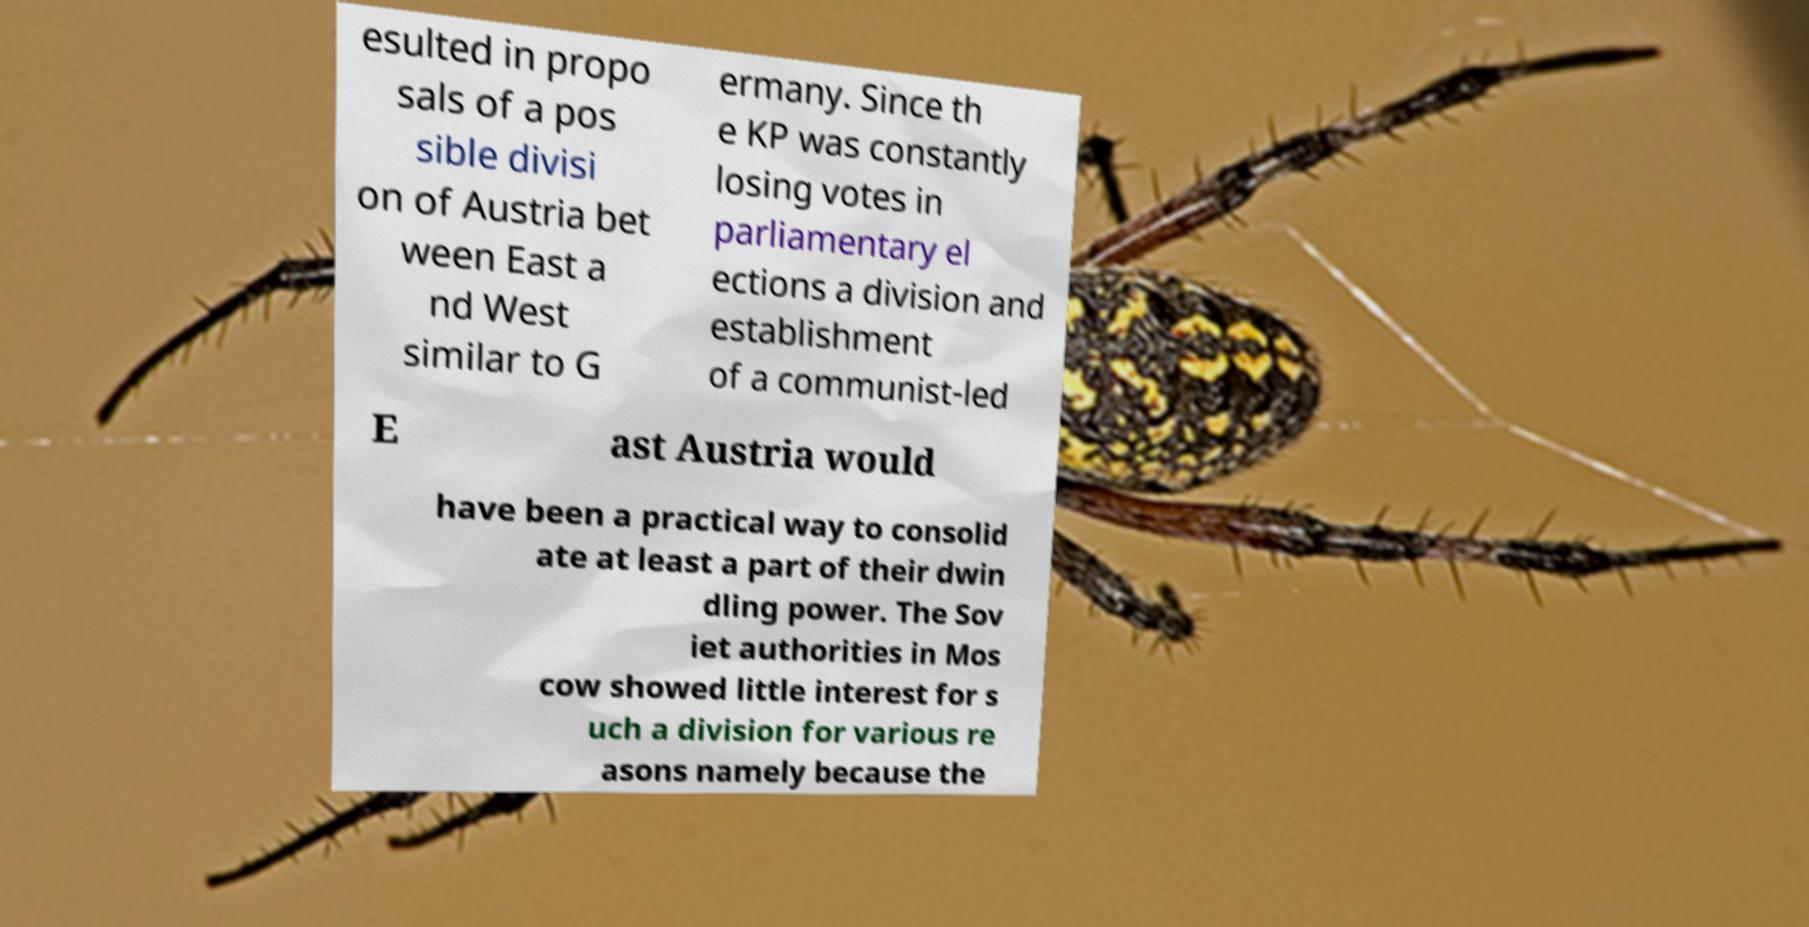Could you assist in decoding the text presented in this image and type it out clearly? esulted in propo sals of a pos sible divisi on of Austria bet ween East a nd West similar to G ermany. Since th e KP was constantly losing votes in parliamentary el ections a division and establishment of a communist-led E ast Austria would have been a practical way to consolid ate at least a part of their dwin dling power. The Sov iet authorities in Mos cow showed little interest for s uch a division for various re asons namely because the 